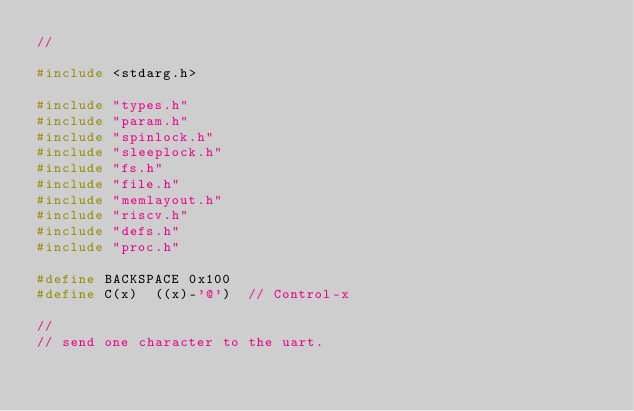Convert code to text. <code><loc_0><loc_0><loc_500><loc_500><_C_>//

#include <stdarg.h>

#include "types.h"
#include "param.h"
#include "spinlock.h"
#include "sleeplock.h"
#include "fs.h"
#include "file.h"
#include "memlayout.h"
#include "riscv.h"
#include "defs.h"
#include "proc.h"

#define BACKSPACE 0x100
#define C(x)  ((x)-'@')  // Control-x

//
// send one character to the uart.</code> 